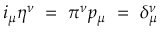<formula> <loc_0><loc_0><loc_500><loc_500>i _ { \mu } \eta ^ { \nu } = \pi ^ { \nu } p _ { \mu } = \delta _ { \mu } ^ { \nu }</formula> 